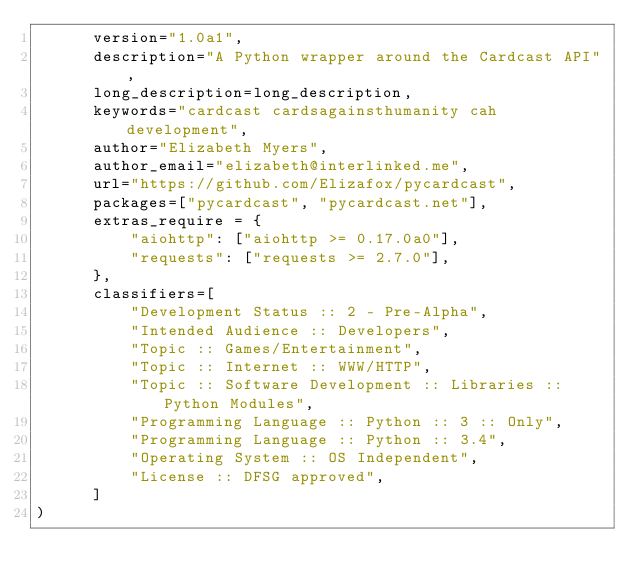<code> <loc_0><loc_0><loc_500><loc_500><_Python_>      version="1.0a1",
      description="A Python wrapper around the Cardcast API",
      long_description=long_description,
      keywords="cardcast cardsagainsthumanity cah development",
      author="Elizabeth Myers",
      author_email="elizabeth@interlinked.me",
      url="https://github.com/Elizafox/pycardcast",
      packages=["pycardcast", "pycardcast.net"],
      extras_require = {
          "aiohttp": ["aiohttp >= 0.17.0a0"],
          "requests": ["requests >= 2.7.0"],
      },
      classifiers=[
          "Development Status :: 2 - Pre-Alpha",
          "Intended Audience :: Developers",
          "Topic :: Games/Entertainment",
          "Topic :: Internet :: WWW/HTTP",
          "Topic :: Software Development :: Libraries :: Python Modules",
          "Programming Language :: Python :: 3 :: Only",
          "Programming Language :: Python :: 3.4",
          "Operating System :: OS Independent",
          "License :: DFSG approved",
      ]
)
</code> 